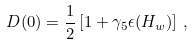Convert formula to latex. <formula><loc_0><loc_0><loc_500><loc_500>D ( 0 ) = \frac { 1 } { 2 } \left [ 1 + \gamma _ { 5 } \epsilon ( H _ { w } ) \right ] \, ,</formula> 